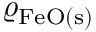Convert formula to latex. <formula><loc_0><loc_0><loc_500><loc_500>\varrho _ { F e O ( s ) }</formula> 